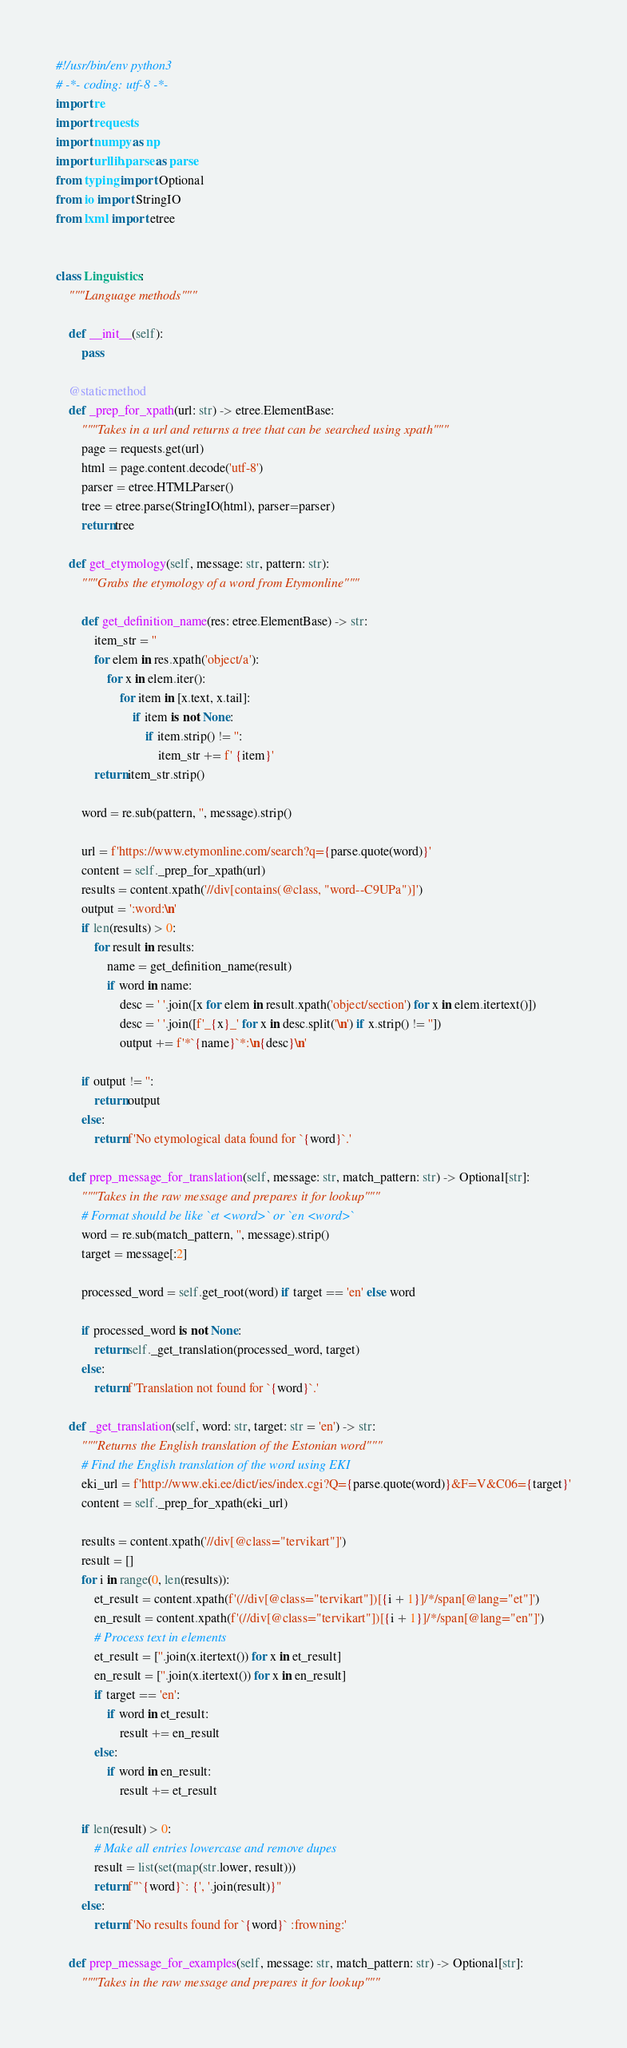<code> <loc_0><loc_0><loc_500><loc_500><_Python_>#!/usr/bin/env python3
# -*- coding: utf-8 -*-
import re
import requests
import numpy as np
import urllib.parse as parse
from typing import Optional
from io import StringIO
from lxml import etree


class Linguistics:
    """Language methods"""

    def __init__(self):
        pass

    @staticmethod
    def _prep_for_xpath(url: str) -> etree.ElementBase:
        """Takes in a url and returns a tree that can be searched using xpath"""
        page = requests.get(url)
        html = page.content.decode('utf-8')
        parser = etree.HTMLParser()
        tree = etree.parse(StringIO(html), parser=parser)
        return tree

    def get_etymology(self, message: str, pattern: str):
        """Grabs the etymology of a word from Etymonline"""

        def get_definition_name(res: etree.ElementBase) -> str:
            item_str = ''
            for elem in res.xpath('object/a'):
                for x in elem.iter():
                    for item in [x.text, x.tail]:
                        if item is not None:
                            if item.strip() != '':
                                item_str += f' {item}'
            return item_str.strip()

        word = re.sub(pattern, '', message).strip()

        url = f'https://www.etymonline.com/search?q={parse.quote(word)}'
        content = self._prep_for_xpath(url)
        results = content.xpath('//div[contains(@class, "word--C9UPa")]')
        output = ':word:\n'
        if len(results) > 0:
            for result in results:
                name = get_definition_name(result)
                if word in name:
                    desc = ' '.join([x for elem in result.xpath('object/section') for x in elem.itertext()])
                    desc = ' '.join([f'_{x}_' for x in desc.split('\n') if x.strip() != ''])
                    output += f'*`{name}`*:\n{desc}\n'

        if output != '':
            return output
        else:
            return f'No etymological data found for `{word}`.'

    def prep_message_for_translation(self, message: str, match_pattern: str) -> Optional[str]:
        """Takes in the raw message and prepares it for lookup"""
        # Format should be like `et <word>` or `en <word>`
        word = re.sub(match_pattern, '', message).strip()
        target = message[:2]

        processed_word = self.get_root(word) if target == 'en' else word

        if processed_word is not None:
            return self._get_translation(processed_word, target)
        else:
            return f'Translation not found for `{word}`.'

    def _get_translation(self, word: str, target: str = 'en') -> str:
        """Returns the English translation of the Estonian word"""
        # Find the English translation of the word using EKI
        eki_url = f'http://www.eki.ee/dict/ies/index.cgi?Q={parse.quote(word)}&F=V&C06={target}'
        content = self._prep_for_xpath(eki_url)

        results = content.xpath('//div[@class="tervikart"]')
        result = []
        for i in range(0, len(results)):
            et_result = content.xpath(f'(//div[@class="tervikart"])[{i + 1}]/*/span[@lang="et"]')
            en_result = content.xpath(f'(//div[@class="tervikart"])[{i + 1}]/*/span[@lang="en"]')
            # Process text in elements
            et_result = [''.join(x.itertext()) for x in et_result]
            en_result = [''.join(x.itertext()) for x in en_result]
            if target == 'en':
                if word in et_result:
                    result += en_result
            else:
                if word in en_result:
                    result += et_result

        if len(result) > 0:
            # Make all entries lowercase and remove dupes
            result = list(set(map(str.lower, result)))
            return f"`{word}`: {', '.join(result)}"
        else:
            return f'No results found for `{word}` :frowning:'

    def prep_message_for_examples(self, message: str, match_pattern: str) -> Optional[str]:
        """Takes in the raw message and prepares it for lookup"""</code> 